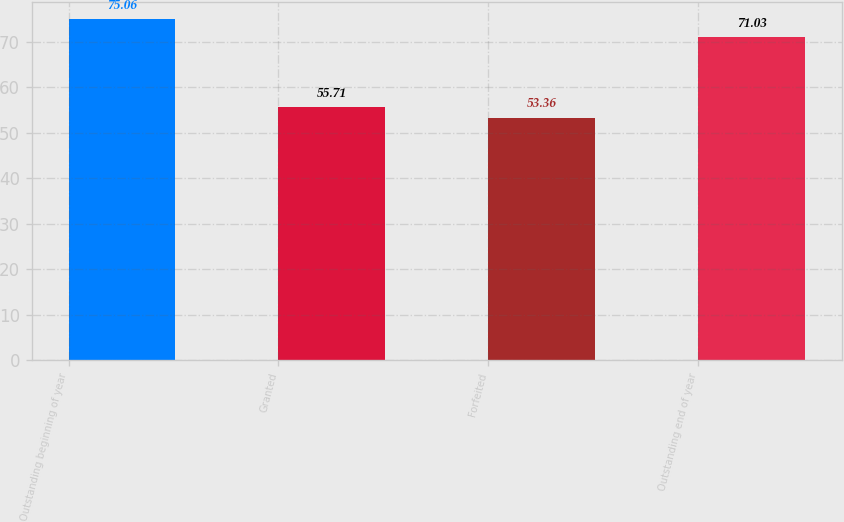Convert chart. <chart><loc_0><loc_0><loc_500><loc_500><bar_chart><fcel>Outstanding beginning of year<fcel>Granted<fcel>Forfeited<fcel>Outstanding end of year<nl><fcel>75.06<fcel>55.71<fcel>53.36<fcel>71.03<nl></chart> 